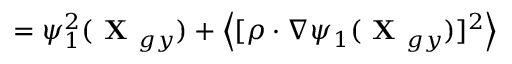Convert formula to latex. <formula><loc_0><loc_0><loc_500><loc_500>= \psi _ { 1 } ^ { 2 } ( X _ { g y } ) + \left \langle [ \rho \cdot \nabla \psi _ { 1 } ( X _ { g y } ) ] ^ { 2 } \right \rangle</formula> 